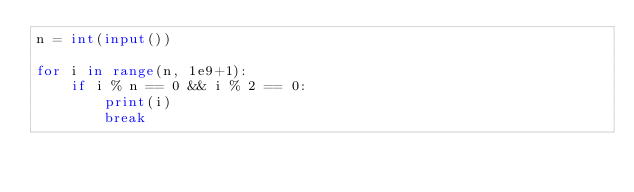<code> <loc_0><loc_0><loc_500><loc_500><_Python_>n = int(input())

for i in range(n, 1e9+1):
    if i % n == 0 && i % 2 == 0:
        print(i)
        break</code> 